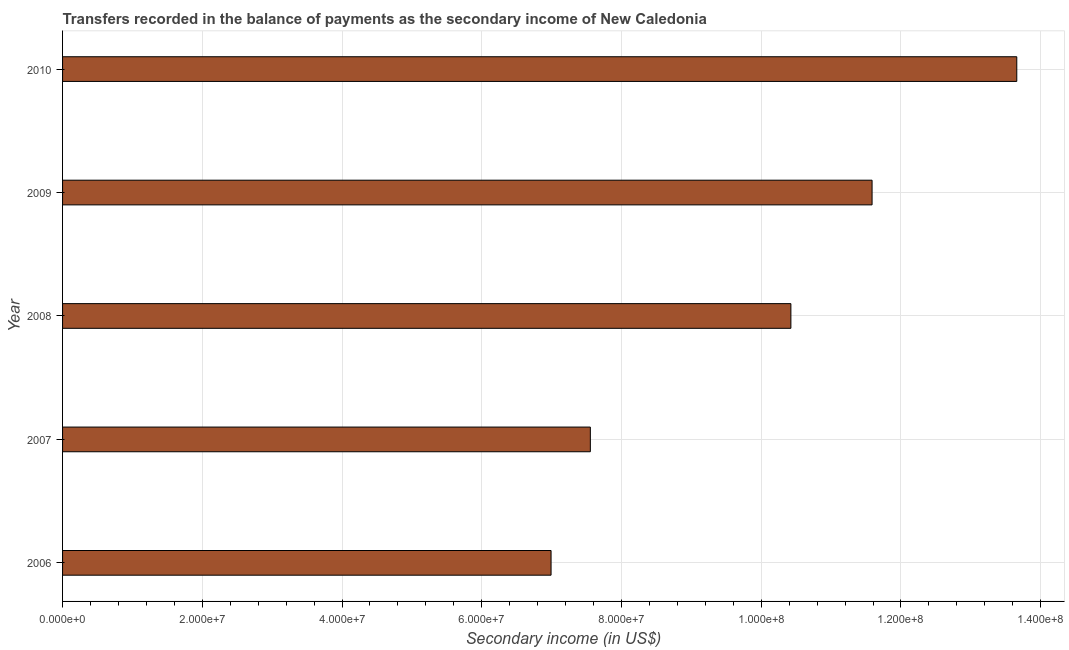Does the graph contain grids?
Offer a very short reply. Yes. What is the title of the graph?
Provide a succinct answer. Transfers recorded in the balance of payments as the secondary income of New Caledonia. What is the label or title of the X-axis?
Give a very brief answer. Secondary income (in US$). What is the label or title of the Y-axis?
Make the answer very short. Year. What is the amount of secondary income in 2007?
Offer a terse response. 7.55e+07. Across all years, what is the maximum amount of secondary income?
Your answer should be compact. 1.37e+08. Across all years, what is the minimum amount of secondary income?
Your answer should be very brief. 6.99e+07. In which year was the amount of secondary income maximum?
Keep it short and to the point. 2010. In which year was the amount of secondary income minimum?
Provide a succinct answer. 2006. What is the sum of the amount of secondary income?
Give a very brief answer. 5.02e+08. What is the difference between the amount of secondary income in 2007 and 2010?
Offer a terse response. -6.10e+07. What is the average amount of secondary income per year?
Offer a terse response. 1.00e+08. What is the median amount of secondary income?
Offer a terse response. 1.04e+08. What is the ratio of the amount of secondary income in 2006 to that in 2010?
Offer a terse response. 0.51. Is the amount of secondary income in 2008 less than that in 2010?
Your answer should be compact. Yes. What is the difference between the highest and the second highest amount of secondary income?
Provide a succinct answer. 2.07e+07. Is the sum of the amount of secondary income in 2008 and 2010 greater than the maximum amount of secondary income across all years?
Offer a terse response. Yes. What is the difference between the highest and the lowest amount of secondary income?
Make the answer very short. 6.67e+07. Are all the bars in the graph horizontal?
Provide a succinct answer. Yes. How many years are there in the graph?
Give a very brief answer. 5. Are the values on the major ticks of X-axis written in scientific E-notation?
Offer a terse response. Yes. What is the Secondary income (in US$) of 2006?
Provide a short and direct response. 6.99e+07. What is the Secondary income (in US$) in 2007?
Offer a very short reply. 7.55e+07. What is the Secondary income (in US$) in 2008?
Offer a terse response. 1.04e+08. What is the Secondary income (in US$) of 2009?
Provide a succinct answer. 1.16e+08. What is the Secondary income (in US$) of 2010?
Offer a terse response. 1.37e+08. What is the difference between the Secondary income (in US$) in 2006 and 2007?
Keep it short and to the point. -5.62e+06. What is the difference between the Secondary income (in US$) in 2006 and 2008?
Offer a terse response. -3.43e+07. What is the difference between the Secondary income (in US$) in 2006 and 2009?
Provide a short and direct response. -4.59e+07. What is the difference between the Secondary income (in US$) in 2006 and 2010?
Make the answer very short. -6.67e+07. What is the difference between the Secondary income (in US$) in 2007 and 2008?
Provide a succinct answer. -2.87e+07. What is the difference between the Secondary income (in US$) in 2007 and 2009?
Offer a terse response. -4.03e+07. What is the difference between the Secondary income (in US$) in 2007 and 2010?
Ensure brevity in your answer.  -6.10e+07. What is the difference between the Secondary income (in US$) in 2008 and 2009?
Provide a succinct answer. -1.16e+07. What is the difference between the Secondary income (in US$) in 2008 and 2010?
Your response must be concise. -3.23e+07. What is the difference between the Secondary income (in US$) in 2009 and 2010?
Your response must be concise. -2.07e+07. What is the ratio of the Secondary income (in US$) in 2006 to that in 2007?
Make the answer very short. 0.93. What is the ratio of the Secondary income (in US$) in 2006 to that in 2008?
Your answer should be compact. 0.67. What is the ratio of the Secondary income (in US$) in 2006 to that in 2009?
Provide a short and direct response. 0.6. What is the ratio of the Secondary income (in US$) in 2006 to that in 2010?
Your answer should be very brief. 0.51. What is the ratio of the Secondary income (in US$) in 2007 to that in 2008?
Provide a succinct answer. 0.72. What is the ratio of the Secondary income (in US$) in 2007 to that in 2009?
Make the answer very short. 0.65. What is the ratio of the Secondary income (in US$) in 2007 to that in 2010?
Make the answer very short. 0.55. What is the ratio of the Secondary income (in US$) in 2008 to that in 2009?
Provide a short and direct response. 0.9. What is the ratio of the Secondary income (in US$) in 2008 to that in 2010?
Ensure brevity in your answer.  0.76. What is the ratio of the Secondary income (in US$) in 2009 to that in 2010?
Ensure brevity in your answer.  0.85. 